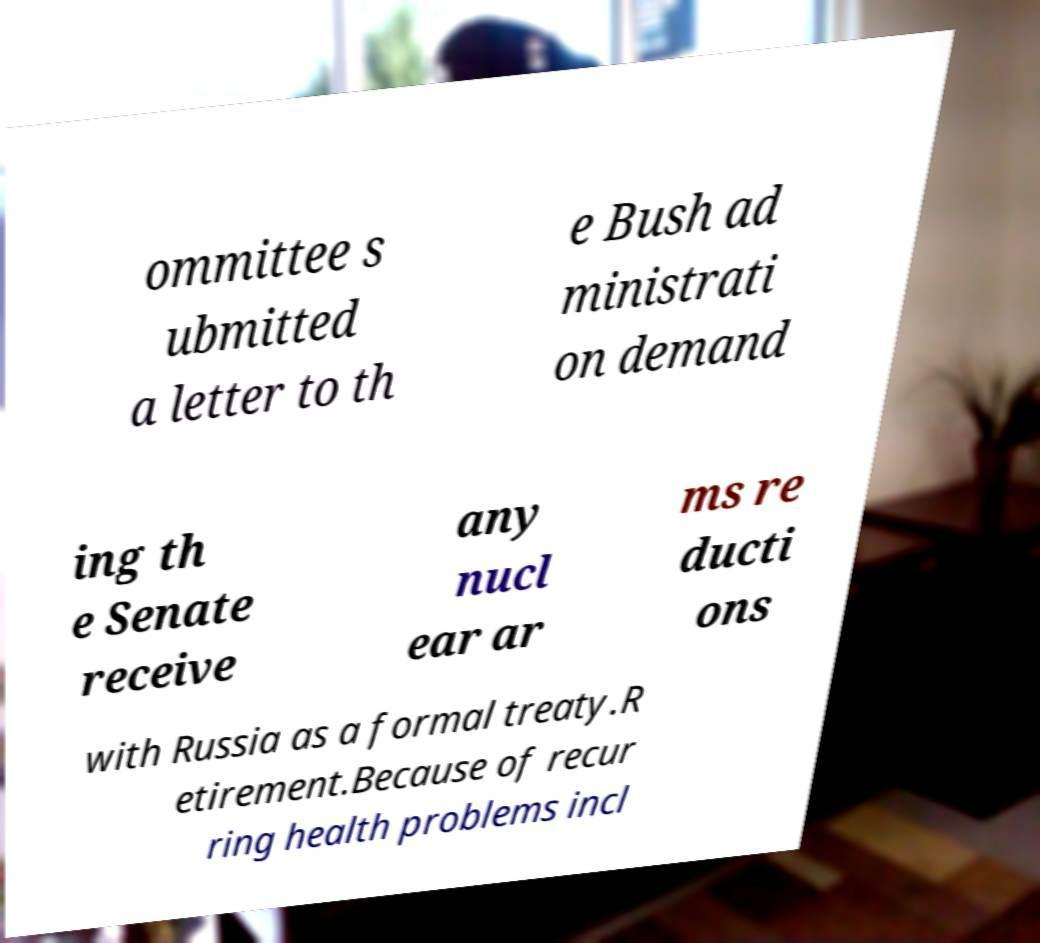Could you assist in decoding the text presented in this image and type it out clearly? ommittee s ubmitted a letter to th e Bush ad ministrati on demand ing th e Senate receive any nucl ear ar ms re ducti ons with Russia as a formal treaty.R etirement.Because of recur ring health problems incl 